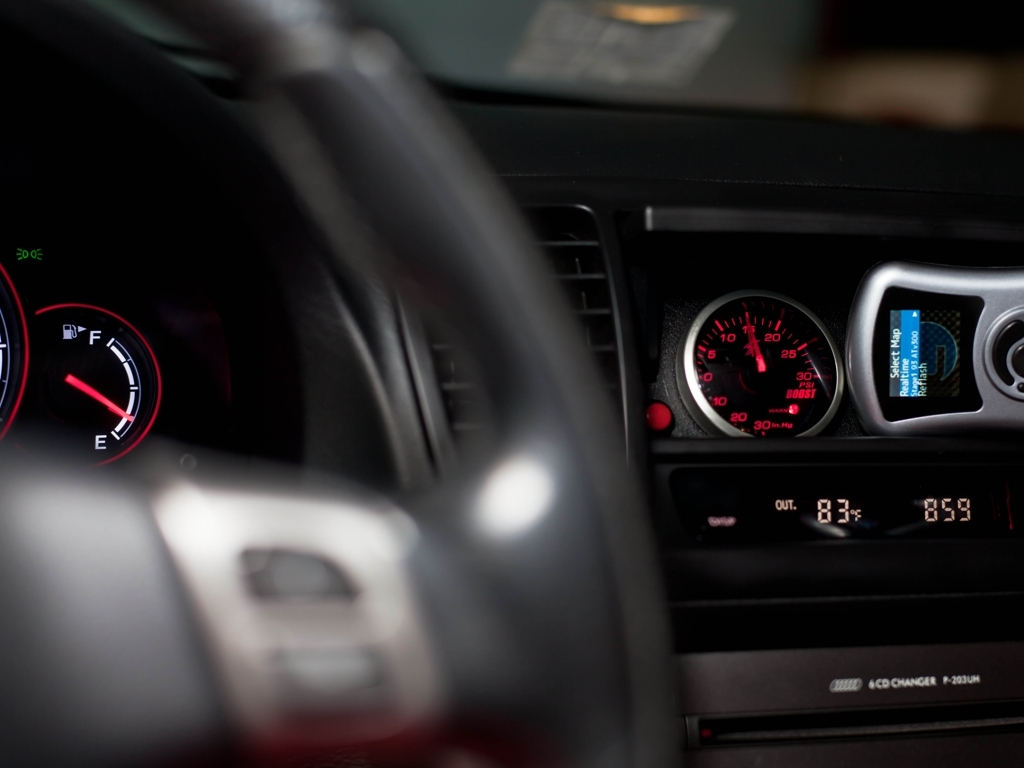What information can we gather about the vehicle from the dashboard indicators and displays? The dashboard displays several indicators: the fuel gauge is near full, and the speedometer is at 0, indicating the car is stationary. The multi-information display suggests that the outside temperature is 83 degrees Fahrenheit and the time is 8:59. There's also a trip meter visible showing 304.8 miles, which might indicate distance driven since last reset. 